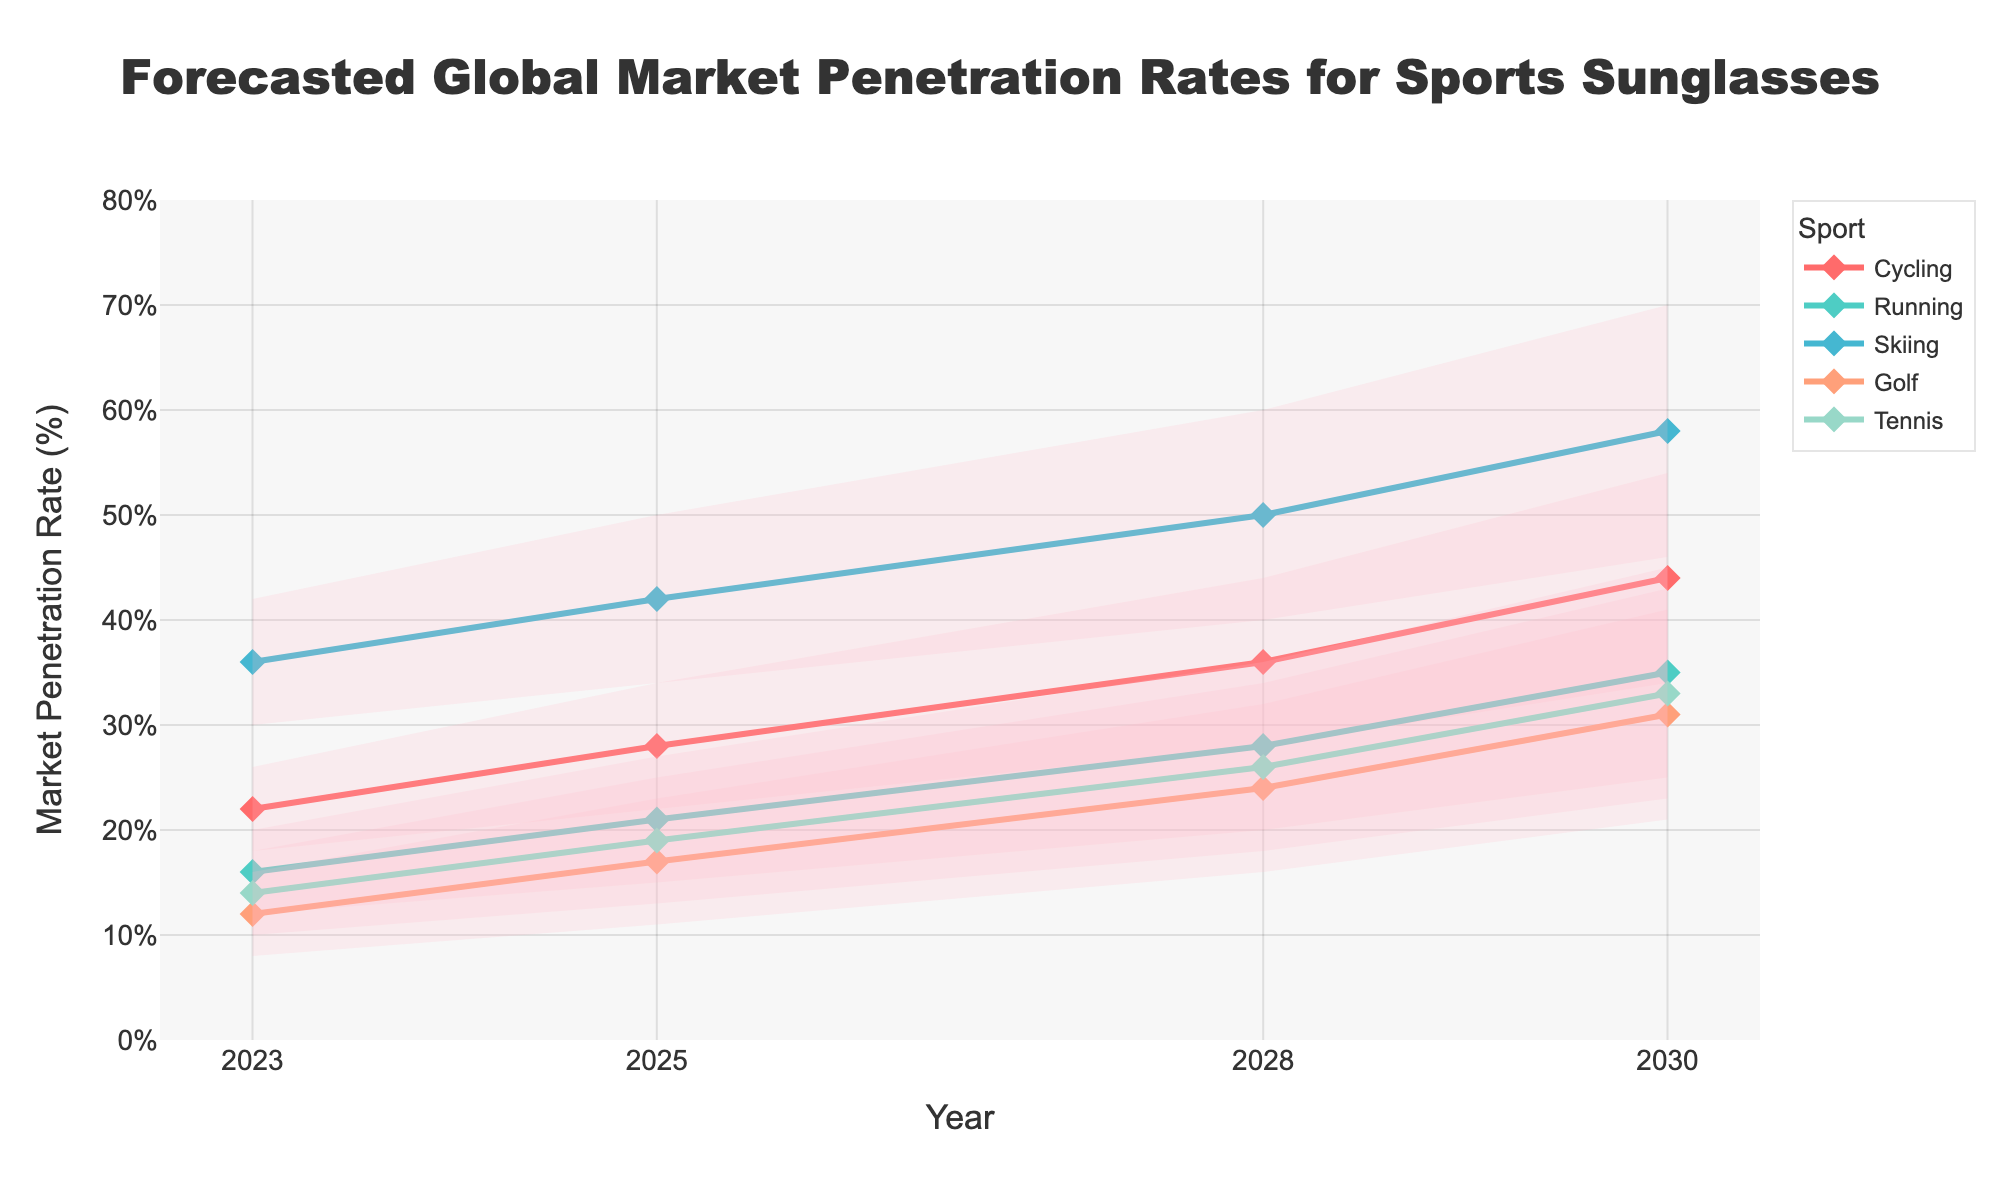What is the title of the chart? The title of the chart is usually shown at the top of the figure. Just read it off from there.
Answer: Forecasted Global Market Penetration Rates for Sports Sunglasses How many sports are displayed in the chart? The number of different sports can be counted from the legend on the right-hand side of the figure.
Answer: Five What is the estimated market penetration rate for Running in 2030 in the Mid Estimate? Locate the line for Running and find the point corresponding to the year 2030. Then check the Mid Estimate value for that year.
Answer: 35% Which sport shows the highest High Estimate market penetration rate in 2030? Compare the High Estimate values for all sports in the year 2030. Identify the highest value and the corresponding sport.
Answer: Skiing What is the increase in the Mid Estimate market penetration rate for Cycling from 2023 to 2028? Find the Mid Estimate values for Cycling in 2023 and 2028, then calculate the difference between these two values.
Answer: 14% Which sport has the lowest Low Estimate market penetration rate in 2025? Compare the Low Estimate values for all sports in the year 2025. Identify the lowest value and the corresponding sport.
Answer: Golf What is the range of the market penetration rate for Tennis in 2028? To find the range, subtract the Low Estimate value from the High Estimate value for Tennis in 2028.
Answer: 16%-34% How does the Mid Estimate market penetration rate for Golf change from 2023 to 2030? Find the Mid Estimate values for Golf in 2023 and 2030. Then compare these values to determine if it increases or decreases.
Answer: Increases Which year shows the highest Mid Estimate market penetration rate for Cycling? Compare the Mid Estimate values for Cycling across all years and identify the year with the highest value.
Answer: 2030 Is the uncertainty in market penetration rates (difference between High Estimate and Low Estimate) increasing or decreasing for Running from 2023 to 2030? Calculate the difference between High and Low Estimates for Running in 2023 and 2030. Compare these values to determine if the uncertainty is increasing or decreasing.
Answer: Increasing 